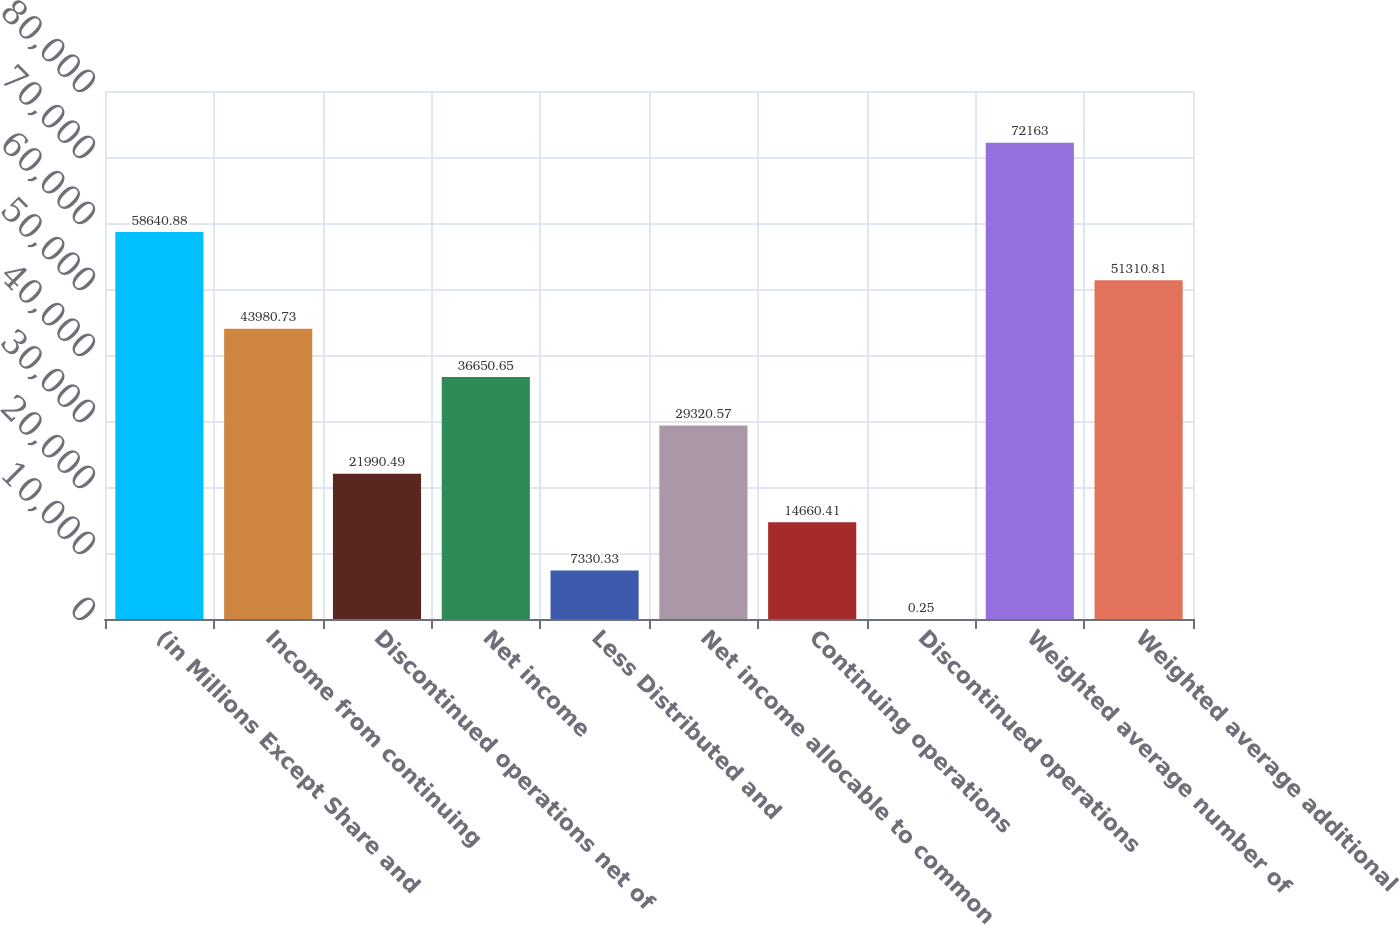<chart> <loc_0><loc_0><loc_500><loc_500><bar_chart><fcel>(in Millions Except Share and<fcel>Income from continuing<fcel>Discontinued operations net of<fcel>Net income<fcel>Less Distributed and<fcel>Net income allocable to common<fcel>Continuing operations<fcel>Discontinued operations<fcel>Weighted average number of<fcel>Weighted average additional<nl><fcel>58640.9<fcel>43980.7<fcel>21990.5<fcel>36650.7<fcel>7330.33<fcel>29320.6<fcel>14660.4<fcel>0.25<fcel>72163<fcel>51310.8<nl></chart> 